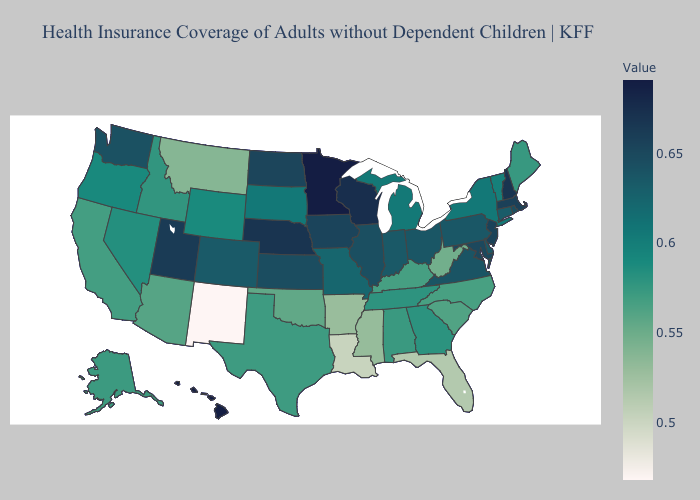Which states hav the highest value in the Northeast?
Short answer required. New Hampshire. Does New Hampshire have the highest value in the Northeast?
Give a very brief answer. Yes. Which states have the lowest value in the MidWest?
Write a very short answer. Michigan. Which states have the highest value in the USA?
Quick response, please. Minnesota. 